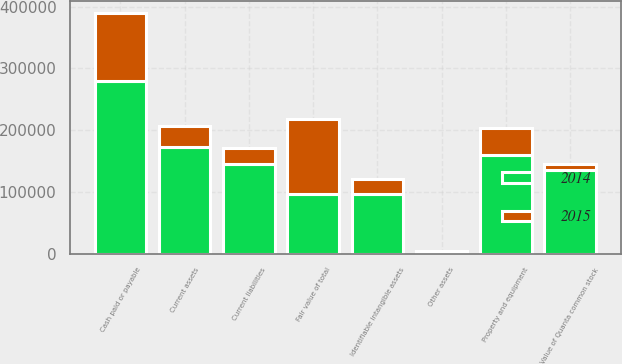<chart> <loc_0><loc_0><loc_500><loc_500><stacked_bar_chart><ecel><fcel>Value of Quanta common stock<fcel>Cash paid or payable<fcel>Fair value of total<fcel>Current assets<fcel>Property and equipment<fcel>Other assets<fcel>Identifiable intangible assets<fcel>Current liabilities<nl><fcel>2015<fcel>10127<fcel>110428<fcel>121556<fcel>35188<fcel>44140<fcel>4<fcel>24987<fcel>24633<nl><fcel>2014<fcel>134538<fcel>279533<fcel>96302<fcel>172121<fcel>159186<fcel>3501<fcel>96302<fcel>145646<nl></chart> 